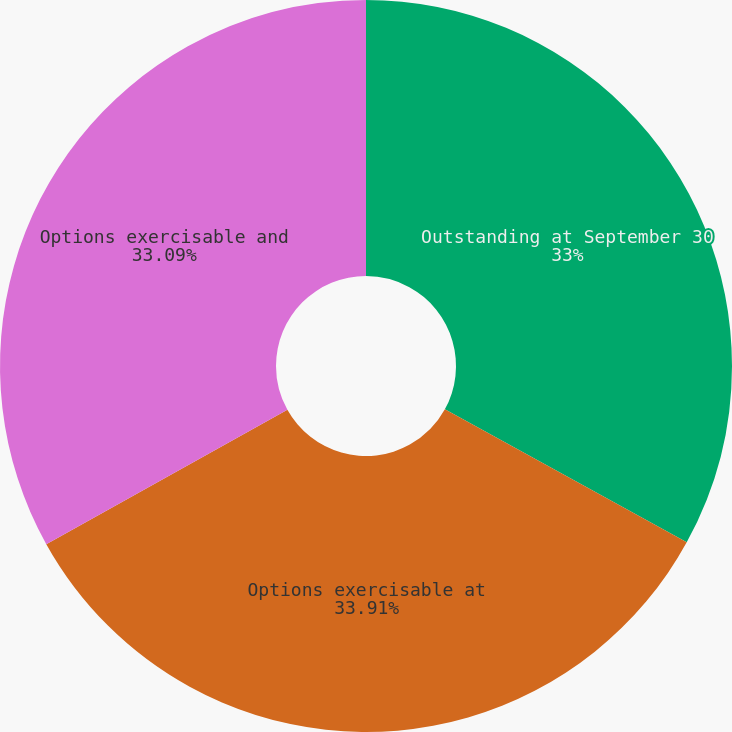Convert chart. <chart><loc_0><loc_0><loc_500><loc_500><pie_chart><fcel>Outstanding at September 30<fcel>Options exercisable at<fcel>Options exercisable and<nl><fcel>33.0%<fcel>33.91%<fcel>33.09%<nl></chart> 